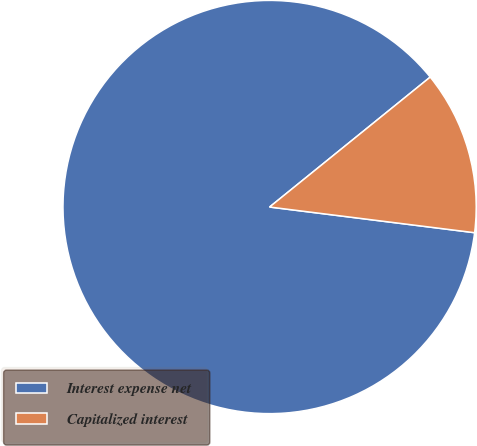<chart> <loc_0><loc_0><loc_500><loc_500><pie_chart><fcel>Interest expense net<fcel>Capitalized interest<nl><fcel>87.19%<fcel>12.81%<nl></chart> 